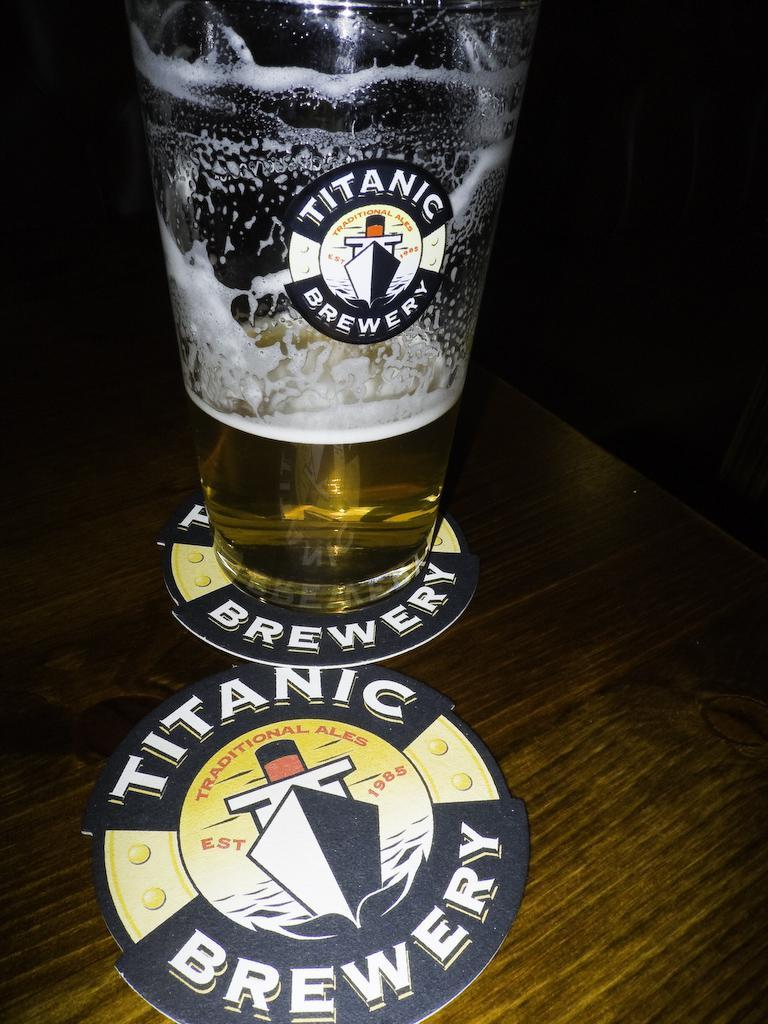<image>
Render a clear and concise summary of the photo. A glass of ale sits on top of a Titanic Brewery coaster. 